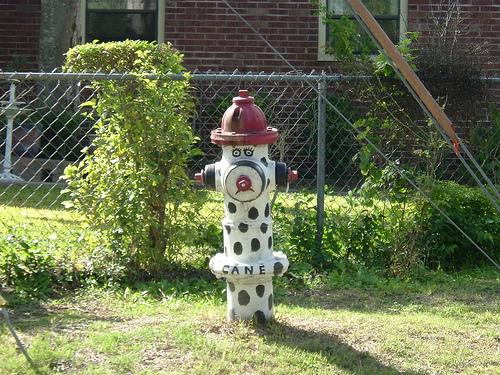What kind of fence is in the picture?
Be succinct. Chain link. What dog is the hydrant depicting?
Give a very brief answer. Dalmatian. What material is the house in the background made of?
Keep it brief. Brick. 